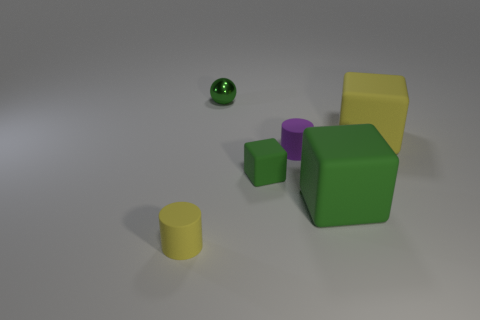Subtract all yellow spheres. Subtract all brown blocks. How many spheres are left? 1 Add 3 large red metal objects. How many objects exist? 9 Subtract all spheres. How many objects are left? 5 Subtract all cyan objects. Subtract all green blocks. How many objects are left? 4 Add 5 cylinders. How many cylinders are left? 7 Add 3 purple shiny objects. How many purple shiny objects exist? 3 Subtract 0 cyan cylinders. How many objects are left? 6 